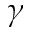<formula> <loc_0><loc_0><loc_500><loc_500>\gamma</formula> 